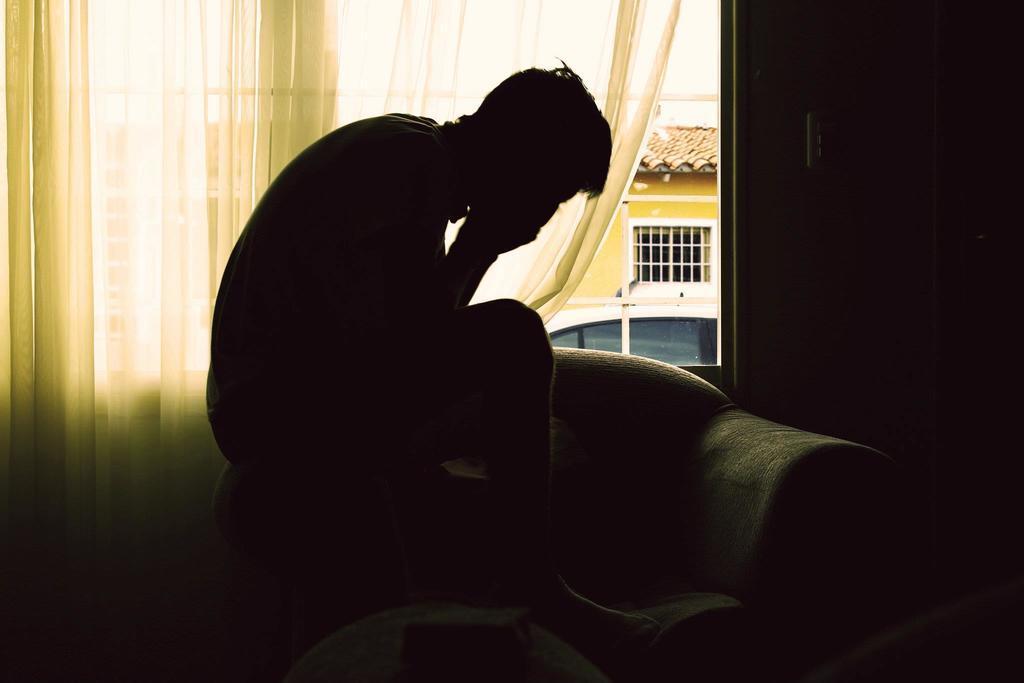Describe this image in one or two sentences. As we can see in the image there is a curtain and a man sitting on sofa. 